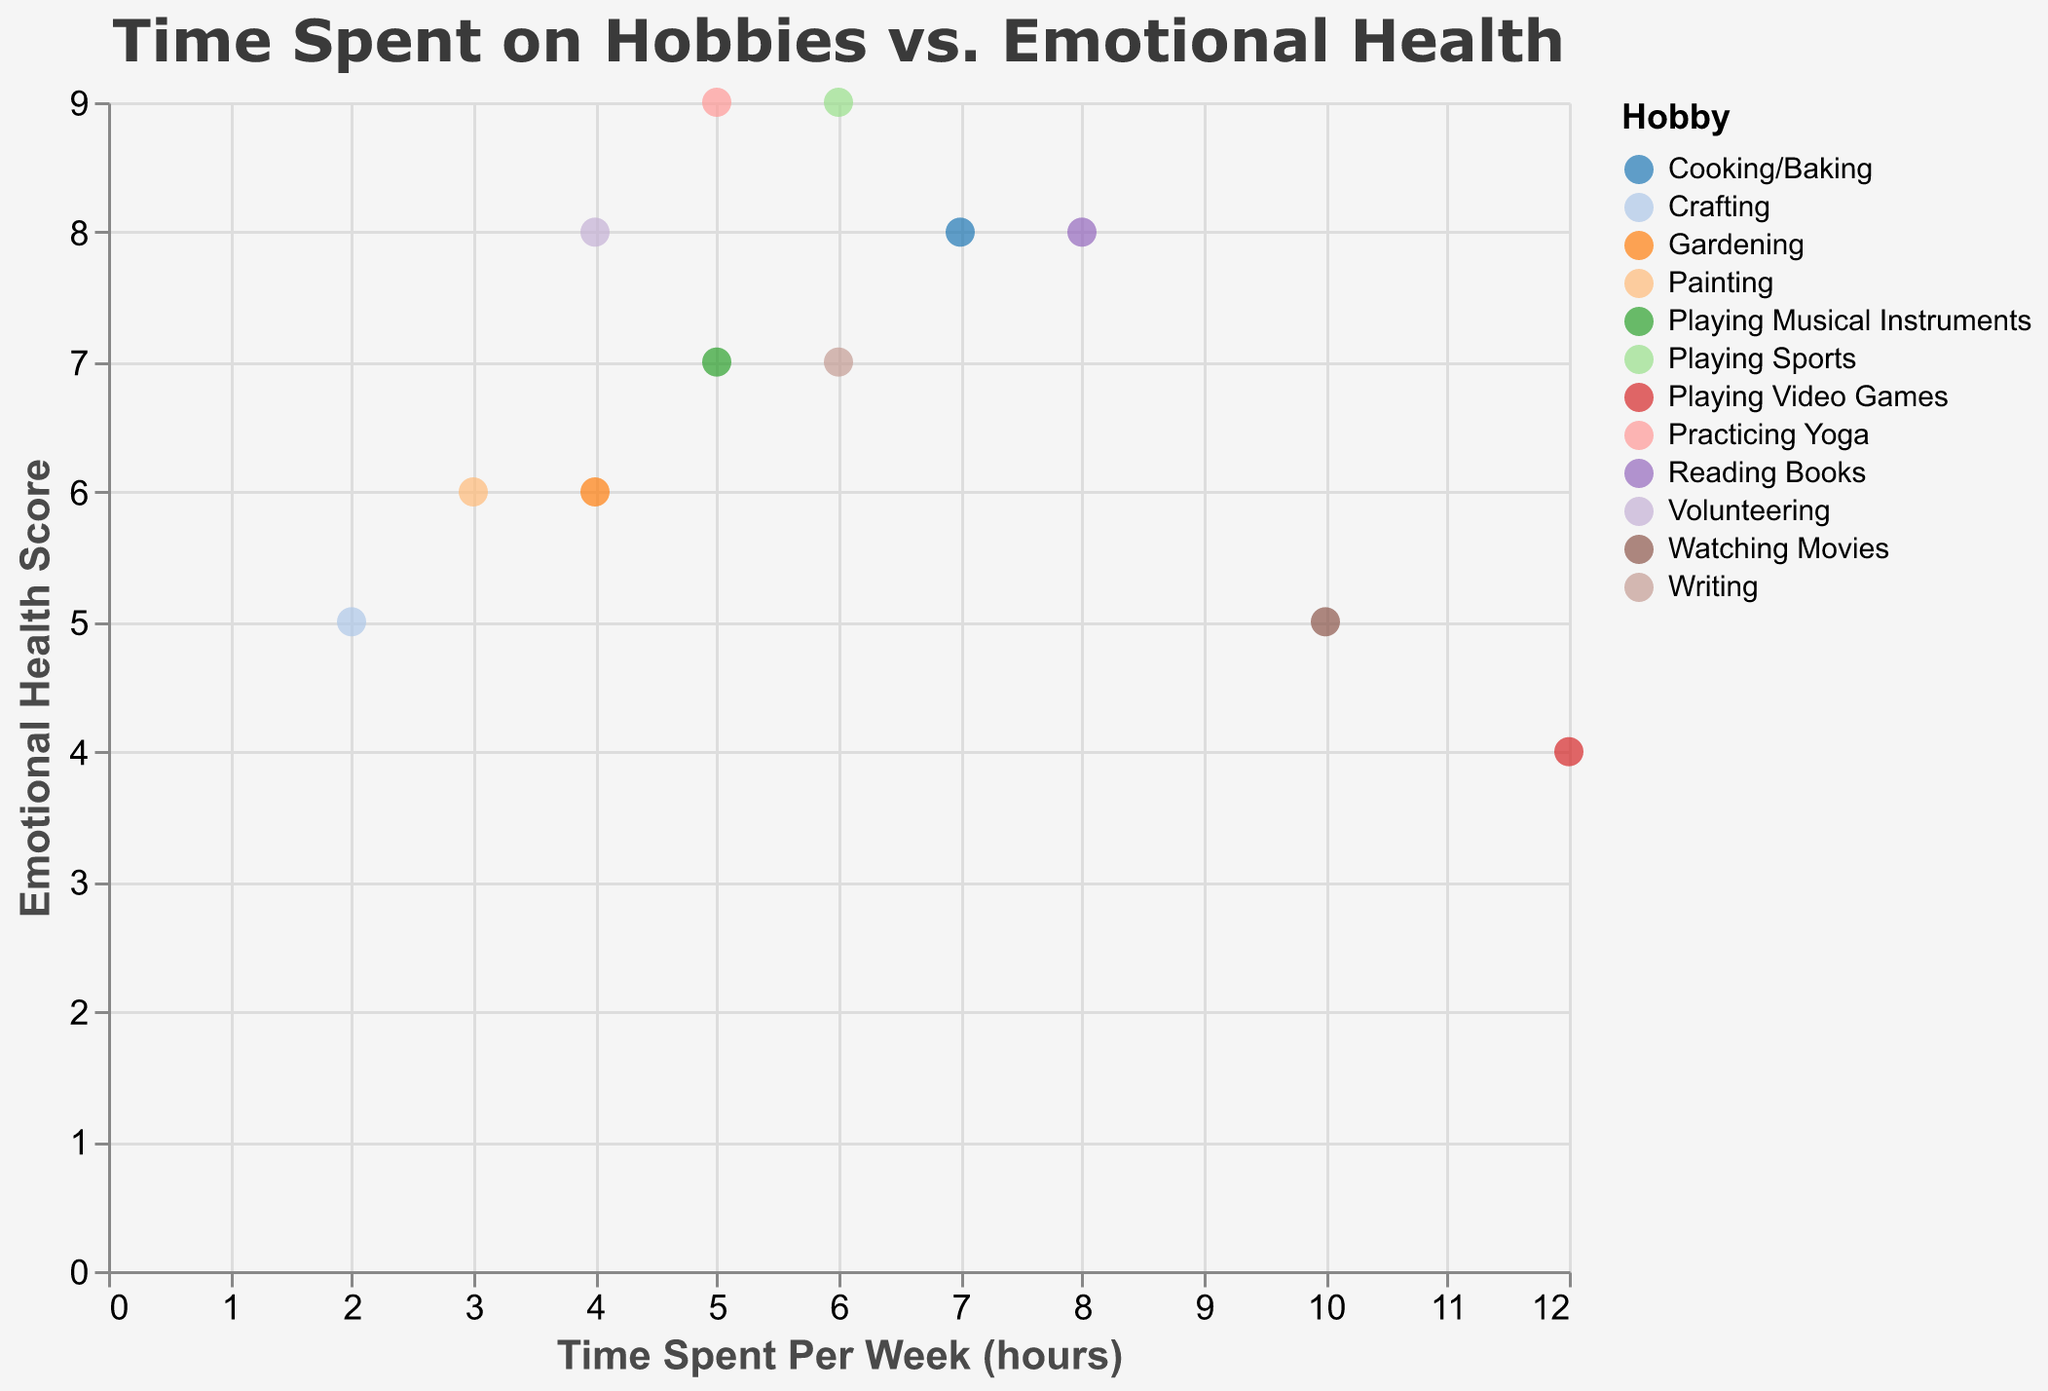How many hobbies are plotted in the scatter plot? The scatter plot contains a distinct color representation for each hobby, counting each color indicates the number of hobbies.
Answer: 12 Which hobby has the highest Emotional Health Score, and what is that score? By observing the y-axis and finding the highest point, the hobby corresponding is "Practicing Yoga" with an Emotional Health Score of 9.
Answer: Practicing Yoga, 9 Compare 'Playing Video Games' and 'Reading Books'. Which hobby has more time spent per week and what are their Emotional Health Scores? 'Playing Video Games' has 12 hours per week (Emotional Health Score 4) while 'Reading Books' has 8 hours (Emotional Health Score 8).
Answer: Playing Video Games (12 hours, 4), Reading Books (8 hours, 8) What is the average Emotional Health Score for hobbies where time spent per week is 6 hours? Identify hobbies with 6 hours per week ('Playing Sports', 'Writing'), add their scores (9+7), and divide by the number of hobbies: (9+7)/2 = 8.
Answer: 8 Which hobby has the lowest Emotional Health Score, and how much time is spent on it per week? Locate the lowest point on the y-axis, the hobby "Playing Video Games" with a score of 4. The time spent is 12 hours per week.
Answer: Playing Video Games, 12 hours Which hobby has a higher Emotional Health Score, 'Cooking/Baking' or 'Watching Movies'? Look at the Emotional Health Scores: 'Cooking/Baking' has a score of 8, 'Watching Movies' has 5.
Answer: Cooking/Baking What is the median Emotional Health Score for all plotted hobbies? List the scores: 7, 8, 6, 9, 6, 5, 8, 4, 9, 7, 8, 5. Rearrange in ascending order: 4, 5, 5, 6, 6, 7, 7, 8, 8, 8, 9, 9. The median is the average of the 6th and 7th scores (7+7)/2 = 7.
Answer: 7 Which hobby with 4 hours per week has the highest Emotional Health Score? Filter the data for time spent per week at 4 hours: 'Gardening' (6), 'Volunteering' (8). 'Volunteering' has the highest score of 8.
Answer: Volunteering 